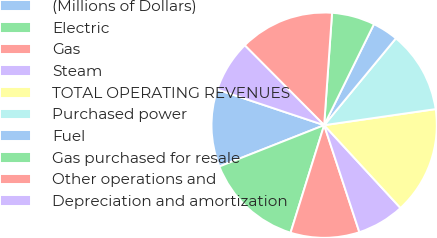Convert chart to OTSL. <chart><loc_0><loc_0><loc_500><loc_500><pie_chart><fcel>(Millions of Dollars)<fcel>Electric<fcel>Gas<fcel>Steam<fcel>TOTAL OPERATING REVENUES<fcel>Purchased power<fcel>Fuel<fcel>Gas purchased for resale<fcel>Other operations and<fcel>Depreciation and amortization<nl><fcel>11.11%<fcel>14.2%<fcel>9.88%<fcel>6.79%<fcel>15.43%<fcel>11.73%<fcel>3.7%<fcel>6.17%<fcel>13.58%<fcel>7.41%<nl></chart> 